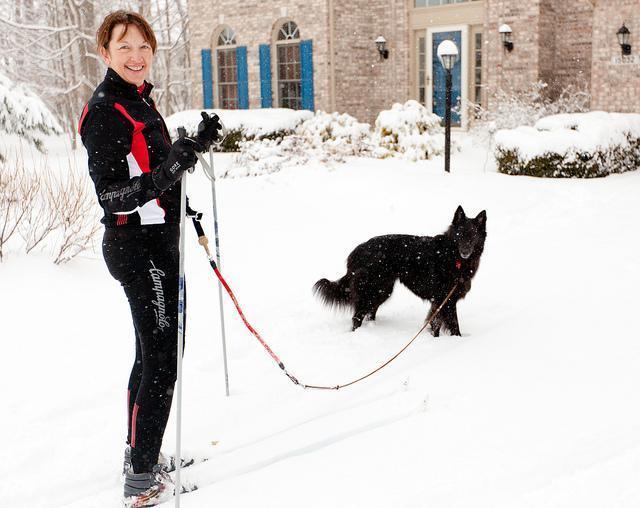How many light fixtures do you see?
Give a very brief answer. 4. 